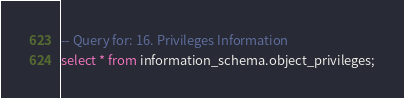Convert code to text. <code><loc_0><loc_0><loc_500><loc_500><_SQL_>-- Query for: 16. Privileges Information
select * from information_schema.object_privileges;

</code> 